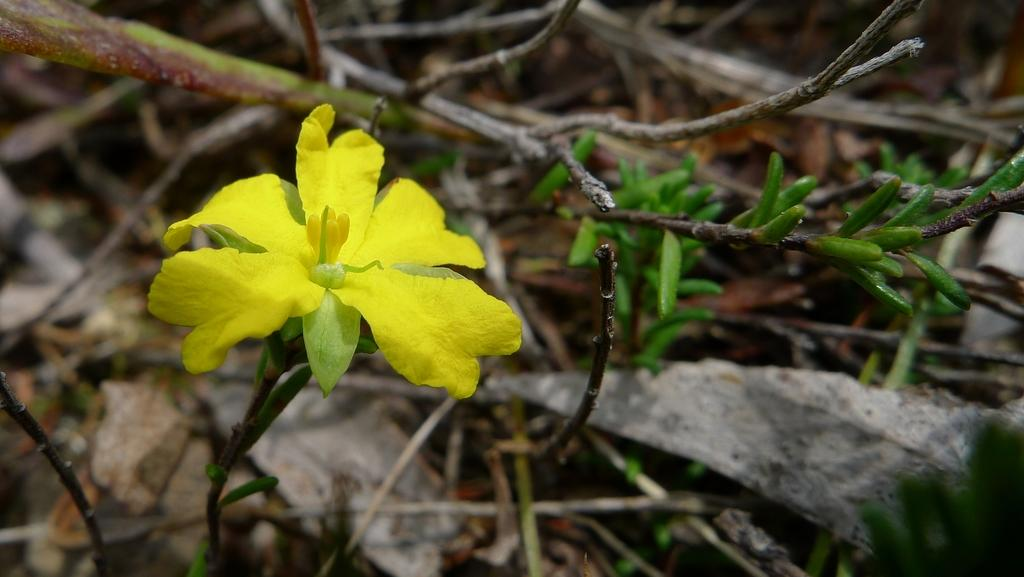What is located in the foreground of the image? There is a flower and a plant in the foreground of the image. Can you describe the plants in the foreground? The flower and plant are both located in the foreground of the image. What can be seen in the background of the image? There are plants visible in the background of the image. What type of wave can be seen crashing on the shore in the image? There is no wave or shore present in the image; it features a flower and plants. 